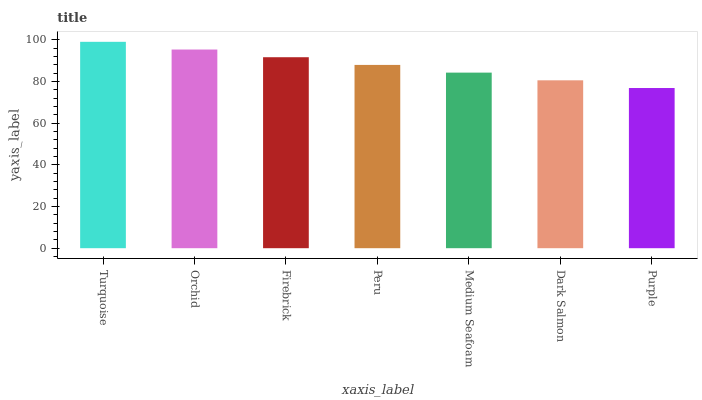Is Purple the minimum?
Answer yes or no. Yes. Is Turquoise the maximum?
Answer yes or no. Yes. Is Orchid the minimum?
Answer yes or no. No. Is Orchid the maximum?
Answer yes or no. No. Is Turquoise greater than Orchid?
Answer yes or no. Yes. Is Orchid less than Turquoise?
Answer yes or no. Yes. Is Orchid greater than Turquoise?
Answer yes or no. No. Is Turquoise less than Orchid?
Answer yes or no. No. Is Peru the high median?
Answer yes or no. Yes. Is Peru the low median?
Answer yes or no. Yes. Is Medium Seafoam the high median?
Answer yes or no. No. Is Medium Seafoam the low median?
Answer yes or no. No. 